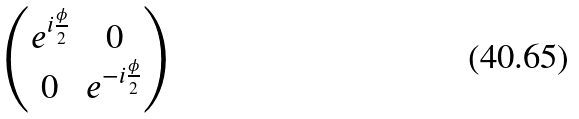<formula> <loc_0><loc_0><loc_500><loc_500>\begin{pmatrix} e ^ { i \frac { \phi } { 2 } } & 0 \\ 0 & e ^ { - i \frac { \phi } { 2 } } \end{pmatrix}</formula> 